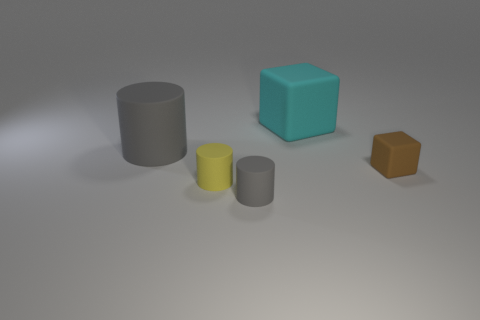There is another gray rubber object that is the same shape as the tiny gray rubber thing; what is its size?
Offer a very short reply. Large. There is a tiny object that is behind the small yellow cylinder; what is its shape?
Keep it short and to the point. Cube. Is the material of the gray thing that is behind the yellow rubber cylinder the same as the block that is to the left of the brown rubber cube?
Your answer should be compact. Yes. What is the shape of the cyan thing?
Ensure brevity in your answer.  Cube. Are there the same number of yellow cylinders to the right of the small gray thing and small red spheres?
Provide a short and direct response. Yes. What is the size of the other cylinder that is the same color as the big rubber cylinder?
Your response must be concise. Small. Is there another yellow thing that has the same material as the yellow object?
Provide a short and direct response. No. There is a gray thing that is behind the brown thing; does it have the same shape as the big matte object that is right of the small yellow cylinder?
Give a very brief answer. No. Is there a brown matte cylinder?
Your response must be concise. No. The object that is the same size as the cyan cube is what color?
Offer a very short reply. Gray. 